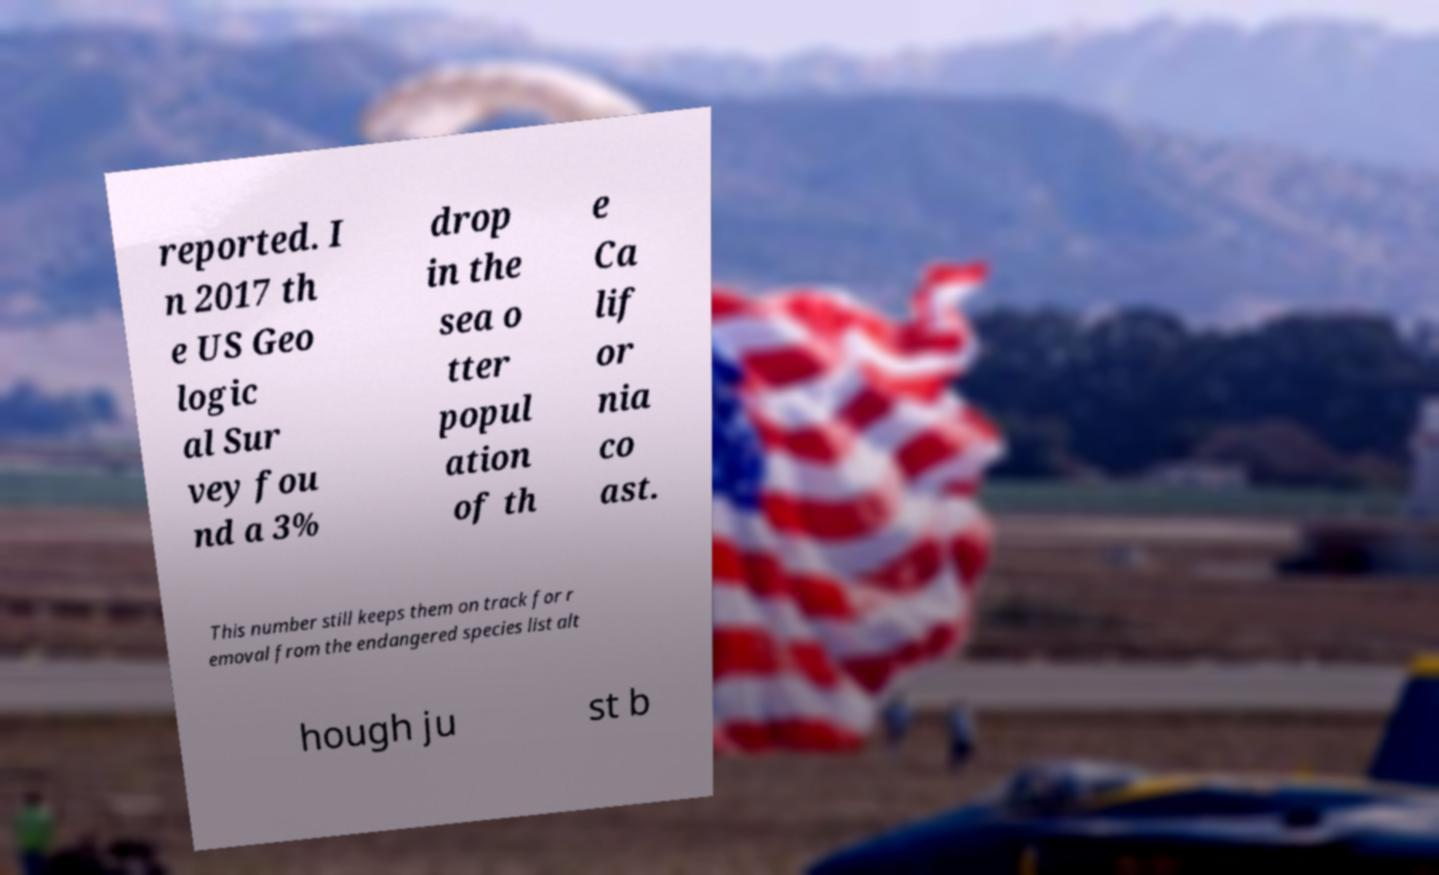There's text embedded in this image that I need extracted. Can you transcribe it verbatim? reported. I n 2017 th e US Geo logic al Sur vey fou nd a 3% drop in the sea o tter popul ation of th e Ca lif or nia co ast. This number still keeps them on track for r emoval from the endangered species list alt hough ju st b 